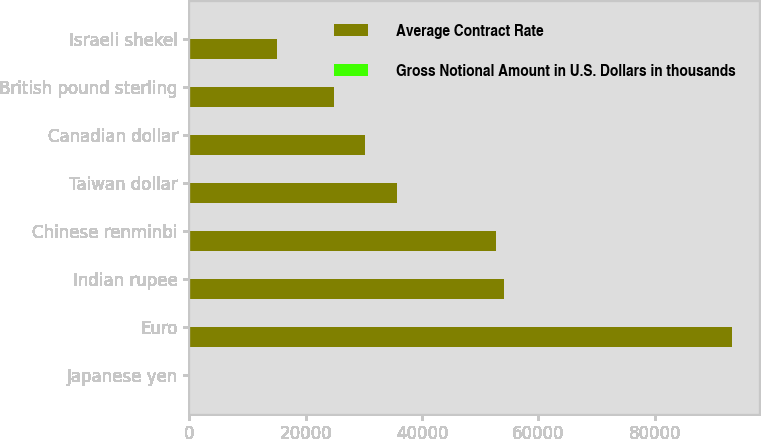<chart> <loc_0><loc_0><loc_500><loc_500><stacked_bar_chart><ecel><fcel>Japanese yen<fcel>Euro<fcel>Indian rupee<fcel>Chinese renminbi<fcel>Taiwan dollar<fcel>Canadian dollar<fcel>British pound sterling<fcel>Israeli shekel<nl><fcel>Average Contract Rate<fcel>79.09<fcel>93316<fcel>54016<fcel>52669<fcel>35633<fcel>30180<fcel>24862<fcel>14982<nl><fcel>Gross Notional Amount in U.S. Dollars in thousands<fcel>79.09<fcel>0.76<fcel>54.44<fcel>6.35<fcel>29.17<fcel>1.01<fcel>0.63<fcel>4.01<nl></chart> 